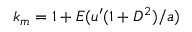<formula> <loc_0><loc_0><loc_500><loc_500>k _ { m } = 1 + E ( u ^ { \prime } ( 1 + D ^ { 2 } ) / a )</formula> 